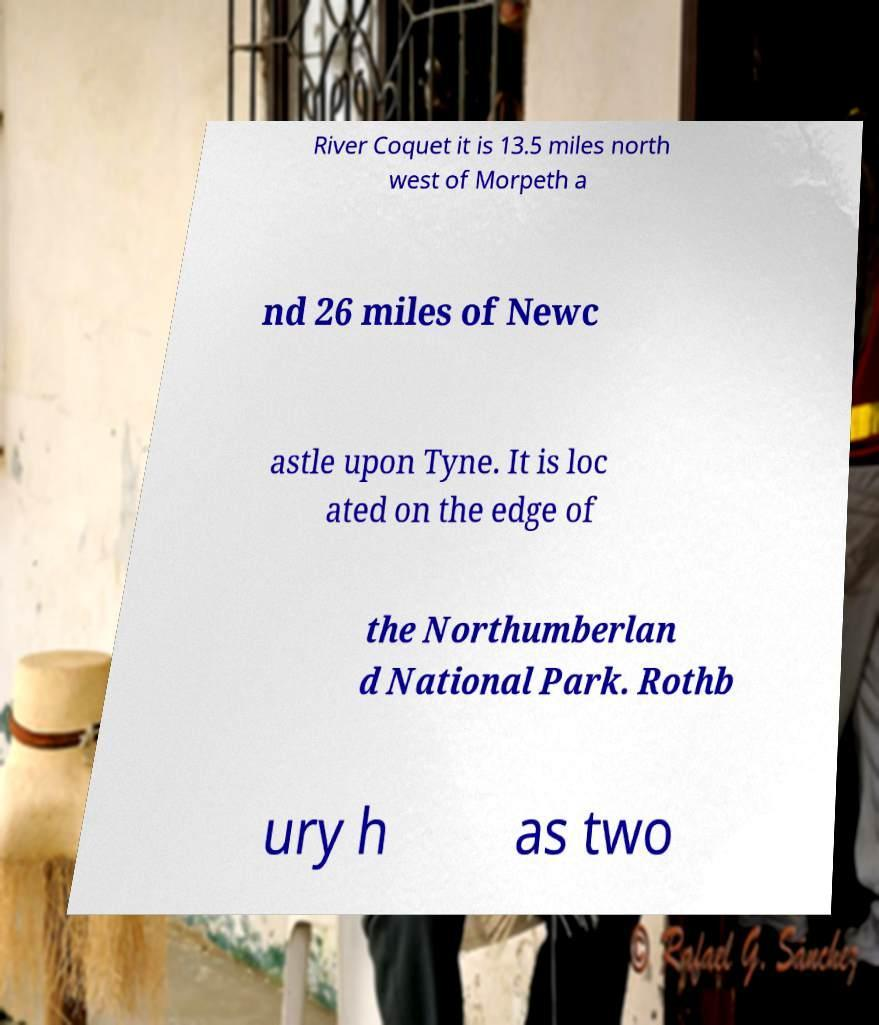Could you extract and type out the text from this image? River Coquet it is 13.5 miles north west of Morpeth a nd 26 miles of Newc astle upon Tyne. It is loc ated on the edge of the Northumberlan d National Park. Rothb ury h as two 